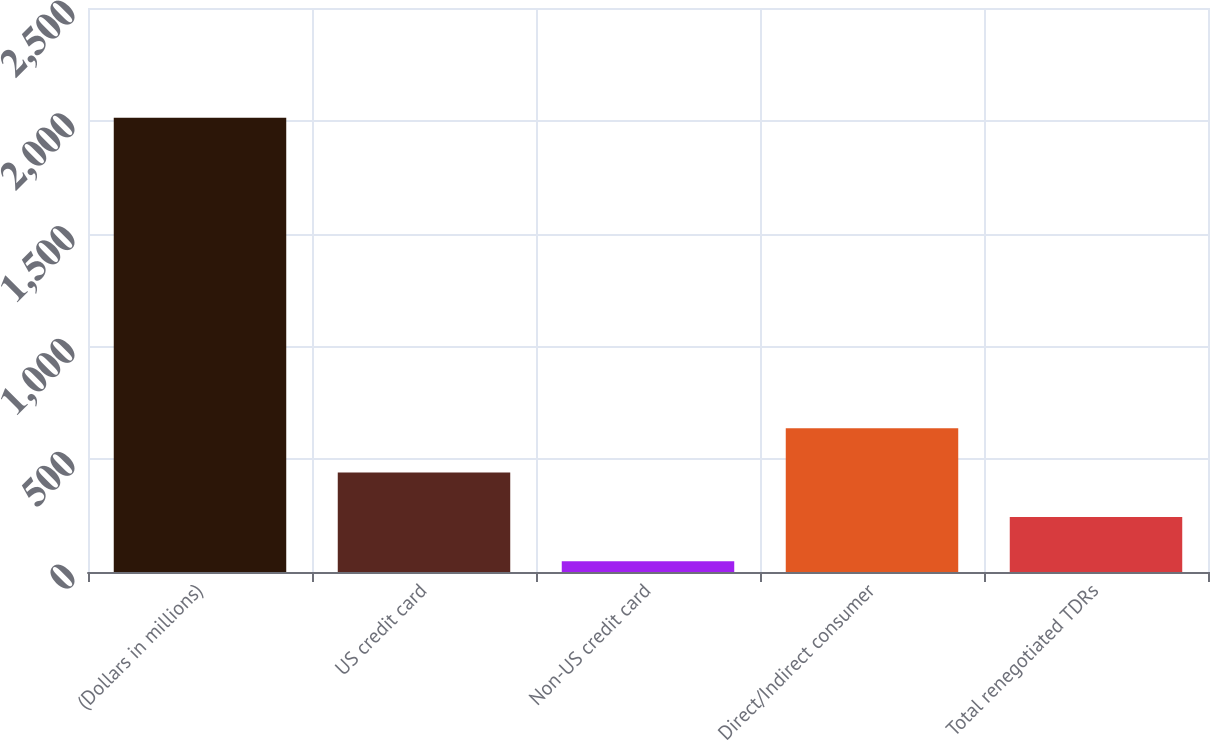Convert chart. <chart><loc_0><loc_0><loc_500><loc_500><bar_chart><fcel>(Dollars in millions)<fcel>US credit card<fcel>Non-US credit card<fcel>Direct/Indirect consumer<fcel>Total renegotiated TDRs<nl><fcel>2014<fcel>440.84<fcel>47.56<fcel>637.48<fcel>244.2<nl></chart> 